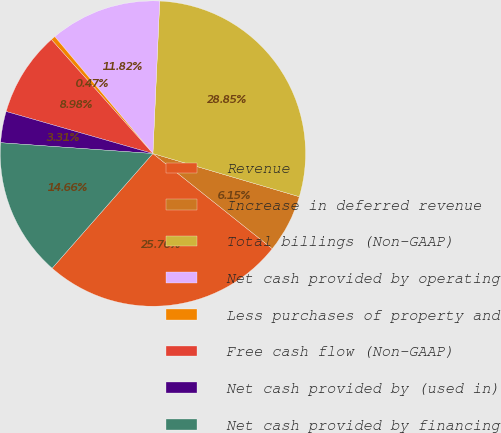<chart> <loc_0><loc_0><loc_500><loc_500><pie_chart><fcel>Revenue<fcel>Increase in deferred revenue<fcel>Total billings (Non-GAAP)<fcel>Net cash provided by operating<fcel>Less purchases of property and<fcel>Free cash flow (Non-GAAP)<fcel>Net cash provided by (used in)<fcel>Net cash provided by financing<nl><fcel>25.76%<fcel>6.15%<fcel>28.85%<fcel>11.82%<fcel>0.47%<fcel>8.98%<fcel>3.31%<fcel>14.66%<nl></chart> 